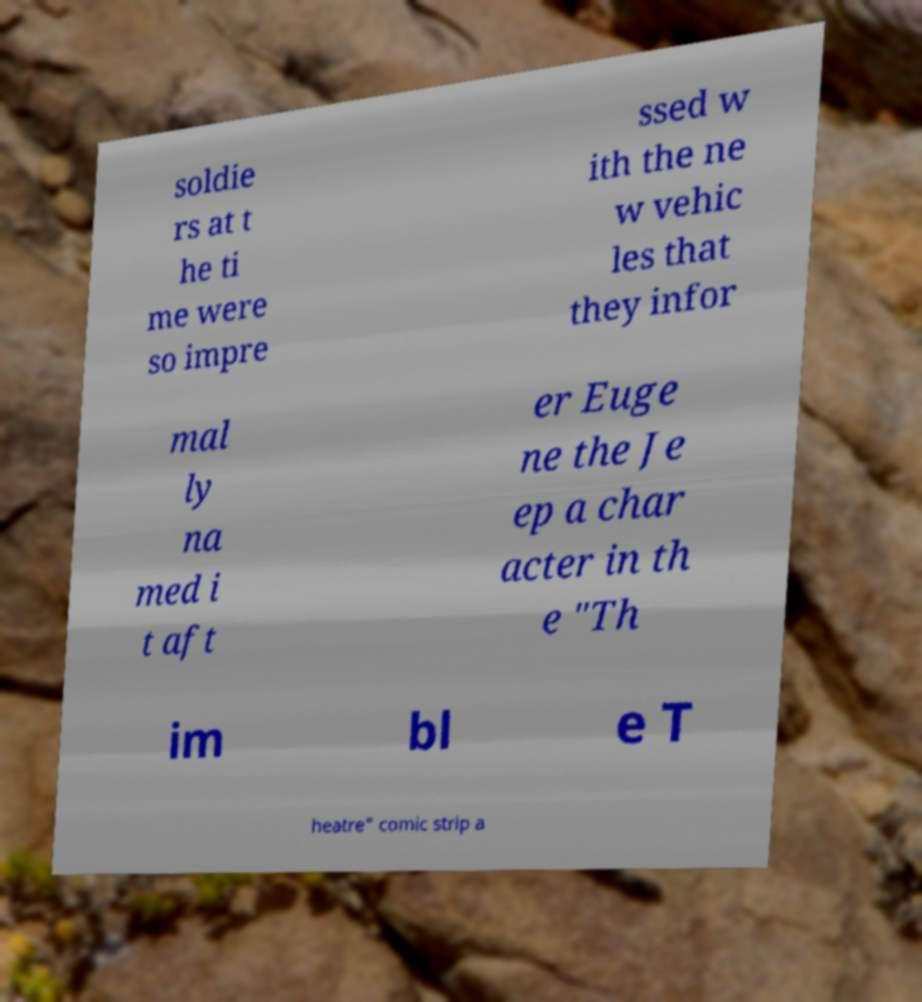Can you accurately transcribe the text from the provided image for me? soldie rs at t he ti me were so impre ssed w ith the ne w vehic les that they infor mal ly na med i t aft er Euge ne the Je ep a char acter in th e "Th im bl e T heatre" comic strip a 